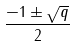<formula> <loc_0><loc_0><loc_500><loc_500>\frac { - 1 \pm { \sqrt { q } } } { 2 }</formula> 